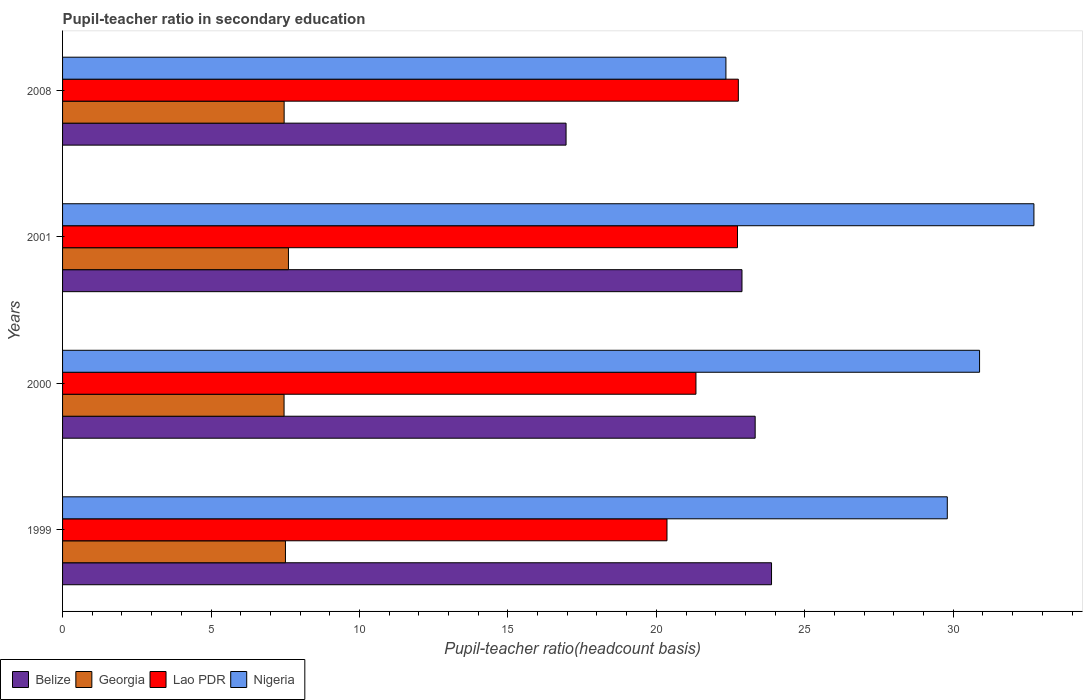How many different coloured bars are there?
Provide a short and direct response. 4. Are the number of bars per tick equal to the number of legend labels?
Keep it short and to the point. Yes. Are the number of bars on each tick of the Y-axis equal?
Ensure brevity in your answer.  Yes. How many bars are there on the 1st tick from the top?
Your answer should be compact. 4. What is the pupil-teacher ratio in secondary education in Lao PDR in 2008?
Ensure brevity in your answer.  22.76. Across all years, what is the maximum pupil-teacher ratio in secondary education in Lao PDR?
Your answer should be compact. 22.76. Across all years, what is the minimum pupil-teacher ratio in secondary education in Nigeria?
Provide a short and direct response. 22.34. In which year was the pupil-teacher ratio in secondary education in Lao PDR minimum?
Your response must be concise. 1999. What is the total pupil-teacher ratio in secondary education in Georgia in the graph?
Keep it short and to the point. 30.04. What is the difference between the pupil-teacher ratio in secondary education in Lao PDR in 1999 and that in 2000?
Offer a very short reply. -0.98. What is the difference between the pupil-teacher ratio in secondary education in Nigeria in 2000 and the pupil-teacher ratio in secondary education in Georgia in 2008?
Your answer should be very brief. 23.42. What is the average pupil-teacher ratio in secondary education in Nigeria per year?
Keep it short and to the point. 28.94. In the year 2001, what is the difference between the pupil-teacher ratio in secondary education in Georgia and pupil-teacher ratio in secondary education in Nigeria?
Provide a short and direct response. -25.11. What is the ratio of the pupil-teacher ratio in secondary education in Georgia in 2000 to that in 2001?
Your response must be concise. 0.98. What is the difference between the highest and the second highest pupil-teacher ratio in secondary education in Nigeria?
Keep it short and to the point. 1.83. What is the difference between the highest and the lowest pupil-teacher ratio in secondary education in Nigeria?
Provide a short and direct response. 10.37. In how many years, is the pupil-teacher ratio in secondary education in Georgia greater than the average pupil-teacher ratio in secondary education in Georgia taken over all years?
Give a very brief answer. 1. Is the sum of the pupil-teacher ratio in secondary education in Lao PDR in 1999 and 2008 greater than the maximum pupil-teacher ratio in secondary education in Georgia across all years?
Provide a short and direct response. Yes. Is it the case that in every year, the sum of the pupil-teacher ratio in secondary education in Nigeria and pupil-teacher ratio in secondary education in Belize is greater than the sum of pupil-teacher ratio in secondary education in Georgia and pupil-teacher ratio in secondary education in Lao PDR?
Give a very brief answer. No. What does the 1st bar from the top in 1999 represents?
Give a very brief answer. Nigeria. What does the 4th bar from the bottom in 2008 represents?
Give a very brief answer. Nigeria. How many bars are there?
Provide a succinct answer. 16. Are all the bars in the graph horizontal?
Offer a very short reply. Yes. Does the graph contain grids?
Make the answer very short. No. How many legend labels are there?
Offer a very short reply. 4. How are the legend labels stacked?
Offer a terse response. Horizontal. What is the title of the graph?
Your answer should be compact. Pupil-teacher ratio in secondary education. Does "East Asia (developing only)" appear as one of the legend labels in the graph?
Ensure brevity in your answer.  No. What is the label or title of the X-axis?
Make the answer very short. Pupil-teacher ratio(headcount basis). What is the label or title of the Y-axis?
Your answer should be compact. Years. What is the Pupil-teacher ratio(headcount basis) of Belize in 1999?
Offer a terse response. 23.88. What is the Pupil-teacher ratio(headcount basis) of Georgia in 1999?
Offer a terse response. 7.51. What is the Pupil-teacher ratio(headcount basis) of Lao PDR in 1999?
Your response must be concise. 20.36. What is the Pupil-teacher ratio(headcount basis) in Nigeria in 1999?
Provide a short and direct response. 29.8. What is the Pupil-teacher ratio(headcount basis) in Belize in 2000?
Provide a succinct answer. 23.33. What is the Pupil-teacher ratio(headcount basis) in Georgia in 2000?
Keep it short and to the point. 7.46. What is the Pupil-teacher ratio(headcount basis) of Lao PDR in 2000?
Provide a short and direct response. 21.33. What is the Pupil-teacher ratio(headcount basis) in Nigeria in 2000?
Your response must be concise. 30.89. What is the Pupil-teacher ratio(headcount basis) of Belize in 2001?
Your answer should be compact. 22.88. What is the Pupil-teacher ratio(headcount basis) in Georgia in 2001?
Provide a short and direct response. 7.61. What is the Pupil-teacher ratio(headcount basis) in Lao PDR in 2001?
Ensure brevity in your answer.  22.73. What is the Pupil-teacher ratio(headcount basis) in Nigeria in 2001?
Give a very brief answer. 32.72. What is the Pupil-teacher ratio(headcount basis) of Belize in 2008?
Ensure brevity in your answer.  16.96. What is the Pupil-teacher ratio(headcount basis) in Georgia in 2008?
Make the answer very short. 7.46. What is the Pupil-teacher ratio(headcount basis) in Lao PDR in 2008?
Give a very brief answer. 22.76. What is the Pupil-teacher ratio(headcount basis) of Nigeria in 2008?
Keep it short and to the point. 22.34. Across all years, what is the maximum Pupil-teacher ratio(headcount basis) of Belize?
Your answer should be compact. 23.88. Across all years, what is the maximum Pupil-teacher ratio(headcount basis) of Georgia?
Your response must be concise. 7.61. Across all years, what is the maximum Pupil-teacher ratio(headcount basis) in Lao PDR?
Ensure brevity in your answer.  22.76. Across all years, what is the maximum Pupil-teacher ratio(headcount basis) in Nigeria?
Make the answer very short. 32.72. Across all years, what is the minimum Pupil-teacher ratio(headcount basis) of Belize?
Make the answer very short. 16.96. Across all years, what is the minimum Pupil-teacher ratio(headcount basis) in Georgia?
Make the answer very short. 7.46. Across all years, what is the minimum Pupil-teacher ratio(headcount basis) in Lao PDR?
Offer a terse response. 20.36. Across all years, what is the minimum Pupil-teacher ratio(headcount basis) of Nigeria?
Your answer should be very brief. 22.34. What is the total Pupil-teacher ratio(headcount basis) in Belize in the graph?
Offer a terse response. 87.05. What is the total Pupil-teacher ratio(headcount basis) of Georgia in the graph?
Your answer should be compact. 30.04. What is the total Pupil-teacher ratio(headcount basis) of Lao PDR in the graph?
Ensure brevity in your answer.  87.19. What is the total Pupil-teacher ratio(headcount basis) of Nigeria in the graph?
Provide a succinct answer. 115.75. What is the difference between the Pupil-teacher ratio(headcount basis) in Belize in 1999 and that in 2000?
Provide a succinct answer. 0.55. What is the difference between the Pupil-teacher ratio(headcount basis) of Georgia in 1999 and that in 2000?
Your answer should be very brief. 0.05. What is the difference between the Pupil-teacher ratio(headcount basis) of Lao PDR in 1999 and that in 2000?
Give a very brief answer. -0.98. What is the difference between the Pupil-teacher ratio(headcount basis) in Nigeria in 1999 and that in 2000?
Offer a terse response. -1.09. What is the difference between the Pupil-teacher ratio(headcount basis) in Belize in 1999 and that in 2001?
Make the answer very short. 1. What is the difference between the Pupil-teacher ratio(headcount basis) in Georgia in 1999 and that in 2001?
Your answer should be compact. -0.1. What is the difference between the Pupil-teacher ratio(headcount basis) in Lao PDR in 1999 and that in 2001?
Give a very brief answer. -2.37. What is the difference between the Pupil-teacher ratio(headcount basis) in Nigeria in 1999 and that in 2001?
Ensure brevity in your answer.  -2.92. What is the difference between the Pupil-teacher ratio(headcount basis) in Belize in 1999 and that in 2008?
Offer a very short reply. 6.92. What is the difference between the Pupil-teacher ratio(headcount basis) in Georgia in 1999 and that in 2008?
Your response must be concise. 0.04. What is the difference between the Pupil-teacher ratio(headcount basis) of Lao PDR in 1999 and that in 2008?
Your answer should be compact. -2.4. What is the difference between the Pupil-teacher ratio(headcount basis) of Nigeria in 1999 and that in 2008?
Keep it short and to the point. 7.46. What is the difference between the Pupil-teacher ratio(headcount basis) of Belize in 2000 and that in 2001?
Provide a succinct answer. 0.44. What is the difference between the Pupil-teacher ratio(headcount basis) in Georgia in 2000 and that in 2001?
Provide a short and direct response. -0.15. What is the difference between the Pupil-teacher ratio(headcount basis) of Lao PDR in 2000 and that in 2001?
Provide a short and direct response. -1.4. What is the difference between the Pupil-teacher ratio(headcount basis) in Nigeria in 2000 and that in 2001?
Offer a very short reply. -1.83. What is the difference between the Pupil-teacher ratio(headcount basis) in Belize in 2000 and that in 2008?
Give a very brief answer. 6.37. What is the difference between the Pupil-teacher ratio(headcount basis) in Georgia in 2000 and that in 2008?
Provide a succinct answer. -0. What is the difference between the Pupil-teacher ratio(headcount basis) in Lao PDR in 2000 and that in 2008?
Ensure brevity in your answer.  -1.43. What is the difference between the Pupil-teacher ratio(headcount basis) in Nigeria in 2000 and that in 2008?
Offer a very short reply. 8.54. What is the difference between the Pupil-teacher ratio(headcount basis) of Belize in 2001 and that in 2008?
Provide a short and direct response. 5.93. What is the difference between the Pupil-teacher ratio(headcount basis) in Georgia in 2001 and that in 2008?
Offer a terse response. 0.15. What is the difference between the Pupil-teacher ratio(headcount basis) in Lao PDR in 2001 and that in 2008?
Your answer should be compact. -0.03. What is the difference between the Pupil-teacher ratio(headcount basis) of Nigeria in 2001 and that in 2008?
Offer a very short reply. 10.37. What is the difference between the Pupil-teacher ratio(headcount basis) in Belize in 1999 and the Pupil-teacher ratio(headcount basis) in Georgia in 2000?
Give a very brief answer. 16.42. What is the difference between the Pupil-teacher ratio(headcount basis) in Belize in 1999 and the Pupil-teacher ratio(headcount basis) in Lao PDR in 2000?
Your answer should be compact. 2.55. What is the difference between the Pupil-teacher ratio(headcount basis) of Belize in 1999 and the Pupil-teacher ratio(headcount basis) of Nigeria in 2000?
Provide a succinct answer. -7.01. What is the difference between the Pupil-teacher ratio(headcount basis) in Georgia in 1999 and the Pupil-teacher ratio(headcount basis) in Lao PDR in 2000?
Offer a terse response. -13.83. What is the difference between the Pupil-teacher ratio(headcount basis) in Georgia in 1999 and the Pupil-teacher ratio(headcount basis) in Nigeria in 2000?
Your answer should be very brief. -23.38. What is the difference between the Pupil-teacher ratio(headcount basis) of Lao PDR in 1999 and the Pupil-teacher ratio(headcount basis) of Nigeria in 2000?
Make the answer very short. -10.53. What is the difference between the Pupil-teacher ratio(headcount basis) in Belize in 1999 and the Pupil-teacher ratio(headcount basis) in Georgia in 2001?
Provide a succinct answer. 16.27. What is the difference between the Pupil-teacher ratio(headcount basis) in Belize in 1999 and the Pupil-teacher ratio(headcount basis) in Lao PDR in 2001?
Keep it short and to the point. 1.15. What is the difference between the Pupil-teacher ratio(headcount basis) in Belize in 1999 and the Pupil-teacher ratio(headcount basis) in Nigeria in 2001?
Provide a succinct answer. -8.84. What is the difference between the Pupil-teacher ratio(headcount basis) of Georgia in 1999 and the Pupil-teacher ratio(headcount basis) of Lao PDR in 2001?
Ensure brevity in your answer.  -15.23. What is the difference between the Pupil-teacher ratio(headcount basis) in Georgia in 1999 and the Pupil-teacher ratio(headcount basis) in Nigeria in 2001?
Offer a terse response. -25.21. What is the difference between the Pupil-teacher ratio(headcount basis) in Lao PDR in 1999 and the Pupil-teacher ratio(headcount basis) in Nigeria in 2001?
Offer a terse response. -12.36. What is the difference between the Pupil-teacher ratio(headcount basis) in Belize in 1999 and the Pupil-teacher ratio(headcount basis) in Georgia in 2008?
Keep it short and to the point. 16.42. What is the difference between the Pupil-teacher ratio(headcount basis) of Belize in 1999 and the Pupil-teacher ratio(headcount basis) of Lao PDR in 2008?
Provide a short and direct response. 1.12. What is the difference between the Pupil-teacher ratio(headcount basis) in Belize in 1999 and the Pupil-teacher ratio(headcount basis) in Nigeria in 2008?
Your answer should be very brief. 1.54. What is the difference between the Pupil-teacher ratio(headcount basis) of Georgia in 1999 and the Pupil-teacher ratio(headcount basis) of Lao PDR in 2008?
Your answer should be very brief. -15.25. What is the difference between the Pupil-teacher ratio(headcount basis) in Georgia in 1999 and the Pupil-teacher ratio(headcount basis) in Nigeria in 2008?
Provide a short and direct response. -14.84. What is the difference between the Pupil-teacher ratio(headcount basis) of Lao PDR in 1999 and the Pupil-teacher ratio(headcount basis) of Nigeria in 2008?
Your answer should be compact. -1.99. What is the difference between the Pupil-teacher ratio(headcount basis) in Belize in 2000 and the Pupil-teacher ratio(headcount basis) in Georgia in 2001?
Offer a terse response. 15.72. What is the difference between the Pupil-teacher ratio(headcount basis) of Belize in 2000 and the Pupil-teacher ratio(headcount basis) of Lao PDR in 2001?
Provide a succinct answer. 0.6. What is the difference between the Pupil-teacher ratio(headcount basis) of Belize in 2000 and the Pupil-teacher ratio(headcount basis) of Nigeria in 2001?
Ensure brevity in your answer.  -9.39. What is the difference between the Pupil-teacher ratio(headcount basis) of Georgia in 2000 and the Pupil-teacher ratio(headcount basis) of Lao PDR in 2001?
Keep it short and to the point. -15.27. What is the difference between the Pupil-teacher ratio(headcount basis) of Georgia in 2000 and the Pupil-teacher ratio(headcount basis) of Nigeria in 2001?
Give a very brief answer. -25.26. What is the difference between the Pupil-teacher ratio(headcount basis) of Lao PDR in 2000 and the Pupil-teacher ratio(headcount basis) of Nigeria in 2001?
Offer a very short reply. -11.38. What is the difference between the Pupil-teacher ratio(headcount basis) of Belize in 2000 and the Pupil-teacher ratio(headcount basis) of Georgia in 2008?
Your response must be concise. 15.87. What is the difference between the Pupil-teacher ratio(headcount basis) in Belize in 2000 and the Pupil-teacher ratio(headcount basis) in Lao PDR in 2008?
Offer a terse response. 0.57. What is the difference between the Pupil-teacher ratio(headcount basis) of Belize in 2000 and the Pupil-teacher ratio(headcount basis) of Nigeria in 2008?
Provide a short and direct response. 0.98. What is the difference between the Pupil-teacher ratio(headcount basis) of Georgia in 2000 and the Pupil-teacher ratio(headcount basis) of Lao PDR in 2008?
Give a very brief answer. -15.3. What is the difference between the Pupil-teacher ratio(headcount basis) of Georgia in 2000 and the Pupil-teacher ratio(headcount basis) of Nigeria in 2008?
Make the answer very short. -14.88. What is the difference between the Pupil-teacher ratio(headcount basis) of Lao PDR in 2000 and the Pupil-teacher ratio(headcount basis) of Nigeria in 2008?
Provide a succinct answer. -1.01. What is the difference between the Pupil-teacher ratio(headcount basis) in Belize in 2001 and the Pupil-teacher ratio(headcount basis) in Georgia in 2008?
Offer a terse response. 15.42. What is the difference between the Pupil-teacher ratio(headcount basis) of Belize in 2001 and the Pupil-teacher ratio(headcount basis) of Lao PDR in 2008?
Your answer should be very brief. 0.12. What is the difference between the Pupil-teacher ratio(headcount basis) of Belize in 2001 and the Pupil-teacher ratio(headcount basis) of Nigeria in 2008?
Offer a very short reply. 0.54. What is the difference between the Pupil-teacher ratio(headcount basis) in Georgia in 2001 and the Pupil-teacher ratio(headcount basis) in Lao PDR in 2008?
Provide a short and direct response. -15.15. What is the difference between the Pupil-teacher ratio(headcount basis) of Georgia in 2001 and the Pupil-teacher ratio(headcount basis) of Nigeria in 2008?
Your answer should be very brief. -14.73. What is the difference between the Pupil-teacher ratio(headcount basis) in Lao PDR in 2001 and the Pupil-teacher ratio(headcount basis) in Nigeria in 2008?
Offer a terse response. 0.39. What is the average Pupil-teacher ratio(headcount basis) of Belize per year?
Keep it short and to the point. 21.76. What is the average Pupil-teacher ratio(headcount basis) of Georgia per year?
Your answer should be very brief. 7.51. What is the average Pupil-teacher ratio(headcount basis) of Lao PDR per year?
Offer a terse response. 21.8. What is the average Pupil-teacher ratio(headcount basis) of Nigeria per year?
Offer a very short reply. 28.94. In the year 1999, what is the difference between the Pupil-teacher ratio(headcount basis) of Belize and Pupil-teacher ratio(headcount basis) of Georgia?
Provide a short and direct response. 16.37. In the year 1999, what is the difference between the Pupil-teacher ratio(headcount basis) in Belize and Pupil-teacher ratio(headcount basis) in Lao PDR?
Offer a terse response. 3.52. In the year 1999, what is the difference between the Pupil-teacher ratio(headcount basis) in Belize and Pupil-teacher ratio(headcount basis) in Nigeria?
Provide a succinct answer. -5.92. In the year 1999, what is the difference between the Pupil-teacher ratio(headcount basis) in Georgia and Pupil-teacher ratio(headcount basis) in Lao PDR?
Provide a succinct answer. -12.85. In the year 1999, what is the difference between the Pupil-teacher ratio(headcount basis) in Georgia and Pupil-teacher ratio(headcount basis) in Nigeria?
Ensure brevity in your answer.  -22.29. In the year 1999, what is the difference between the Pupil-teacher ratio(headcount basis) in Lao PDR and Pupil-teacher ratio(headcount basis) in Nigeria?
Your response must be concise. -9.44. In the year 2000, what is the difference between the Pupil-teacher ratio(headcount basis) of Belize and Pupil-teacher ratio(headcount basis) of Georgia?
Offer a very short reply. 15.87. In the year 2000, what is the difference between the Pupil-teacher ratio(headcount basis) of Belize and Pupil-teacher ratio(headcount basis) of Lao PDR?
Your answer should be compact. 1.99. In the year 2000, what is the difference between the Pupil-teacher ratio(headcount basis) in Belize and Pupil-teacher ratio(headcount basis) in Nigeria?
Provide a short and direct response. -7.56. In the year 2000, what is the difference between the Pupil-teacher ratio(headcount basis) in Georgia and Pupil-teacher ratio(headcount basis) in Lao PDR?
Provide a short and direct response. -13.87. In the year 2000, what is the difference between the Pupil-teacher ratio(headcount basis) in Georgia and Pupil-teacher ratio(headcount basis) in Nigeria?
Offer a terse response. -23.43. In the year 2000, what is the difference between the Pupil-teacher ratio(headcount basis) in Lao PDR and Pupil-teacher ratio(headcount basis) in Nigeria?
Give a very brief answer. -9.55. In the year 2001, what is the difference between the Pupil-teacher ratio(headcount basis) in Belize and Pupil-teacher ratio(headcount basis) in Georgia?
Make the answer very short. 15.28. In the year 2001, what is the difference between the Pupil-teacher ratio(headcount basis) of Belize and Pupil-teacher ratio(headcount basis) of Lao PDR?
Provide a short and direct response. 0.15. In the year 2001, what is the difference between the Pupil-teacher ratio(headcount basis) of Belize and Pupil-teacher ratio(headcount basis) of Nigeria?
Give a very brief answer. -9.83. In the year 2001, what is the difference between the Pupil-teacher ratio(headcount basis) in Georgia and Pupil-teacher ratio(headcount basis) in Lao PDR?
Offer a very short reply. -15.12. In the year 2001, what is the difference between the Pupil-teacher ratio(headcount basis) in Georgia and Pupil-teacher ratio(headcount basis) in Nigeria?
Provide a succinct answer. -25.11. In the year 2001, what is the difference between the Pupil-teacher ratio(headcount basis) in Lao PDR and Pupil-teacher ratio(headcount basis) in Nigeria?
Provide a short and direct response. -9.98. In the year 2008, what is the difference between the Pupil-teacher ratio(headcount basis) of Belize and Pupil-teacher ratio(headcount basis) of Georgia?
Provide a short and direct response. 9.5. In the year 2008, what is the difference between the Pupil-teacher ratio(headcount basis) of Belize and Pupil-teacher ratio(headcount basis) of Lao PDR?
Offer a terse response. -5.8. In the year 2008, what is the difference between the Pupil-teacher ratio(headcount basis) of Belize and Pupil-teacher ratio(headcount basis) of Nigeria?
Provide a succinct answer. -5.38. In the year 2008, what is the difference between the Pupil-teacher ratio(headcount basis) of Georgia and Pupil-teacher ratio(headcount basis) of Lao PDR?
Offer a very short reply. -15.3. In the year 2008, what is the difference between the Pupil-teacher ratio(headcount basis) of Georgia and Pupil-teacher ratio(headcount basis) of Nigeria?
Make the answer very short. -14.88. In the year 2008, what is the difference between the Pupil-teacher ratio(headcount basis) of Lao PDR and Pupil-teacher ratio(headcount basis) of Nigeria?
Ensure brevity in your answer.  0.42. What is the ratio of the Pupil-teacher ratio(headcount basis) of Belize in 1999 to that in 2000?
Offer a very short reply. 1.02. What is the ratio of the Pupil-teacher ratio(headcount basis) of Lao PDR in 1999 to that in 2000?
Your answer should be very brief. 0.95. What is the ratio of the Pupil-teacher ratio(headcount basis) in Nigeria in 1999 to that in 2000?
Your answer should be compact. 0.96. What is the ratio of the Pupil-teacher ratio(headcount basis) of Belize in 1999 to that in 2001?
Offer a terse response. 1.04. What is the ratio of the Pupil-teacher ratio(headcount basis) in Georgia in 1999 to that in 2001?
Keep it short and to the point. 0.99. What is the ratio of the Pupil-teacher ratio(headcount basis) in Lao PDR in 1999 to that in 2001?
Keep it short and to the point. 0.9. What is the ratio of the Pupil-teacher ratio(headcount basis) of Nigeria in 1999 to that in 2001?
Make the answer very short. 0.91. What is the ratio of the Pupil-teacher ratio(headcount basis) in Belize in 1999 to that in 2008?
Your answer should be very brief. 1.41. What is the ratio of the Pupil-teacher ratio(headcount basis) in Georgia in 1999 to that in 2008?
Your answer should be very brief. 1.01. What is the ratio of the Pupil-teacher ratio(headcount basis) in Lao PDR in 1999 to that in 2008?
Offer a very short reply. 0.89. What is the ratio of the Pupil-teacher ratio(headcount basis) in Nigeria in 1999 to that in 2008?
Offer a very short reply. 1.33. What is the ratio of the Pupil-teacher ratio(headcount basis) in Belize in 2000 to that in 2001?
Your answer should be very brief. 1.02. What is the ratio of the Pupil-teacher ratio(headcount basis) of Georgia in 2000 to that in 2001?
Provide a succinct answer. 0.98. What is the ratio of the Pupil-teacher ratio(headcount basis) of Lao PDR in 2000 to that in 2001?
Keep it short and to the point. 0.94. What is the ratio of the Pupil-teacher ratio(headcount basis) of Nigeria in 2000 to that in 2001?
Keep it short and to the point. 0.94. What is the ratio of the Pupil-teacher ratio(headcount basis) of Belize in 2000 to that in 2008?
Give a very brief answer. 1.38. What is the ratio of the Pupil-teacher ratio(headcount basis) in Georgia in 2000 to that in 2008?
Your answer should be very brief. 1. What is the ratio of the Pupil-teacher ratio(headcount basis) of Lao PDR in 2000 to that in 2008?
Your answer should be compact. 0.94. What is the ratio of the Pupil-teacher ratio(headcount basis) of Nigeria in 2000 to that in 2008?
Your answer should be compact. 1.38. What is the ratio of the Pupil-teacher ratio(headcount basis) of Belize in 2001 to that in 2008?
Provide a succinct answer. 1.35. What is the ratio of the Pupil-teacher ratio(headcount basis) of Georgia in 2001 to that in 2008?
Provide a short and direct response. 1.02. What is the ratio of the Pupil-teacher ratio(headcount basis) of Nigeria in 2001 to that in 2008?
Provide a short and direct response. 1.46. What is the difference between the highest and the second highest Pupil-teacher ratio(headcount basis) of Belize?
Make the answer very short. 0.55. What is the difference between the highest and the second highest Pupil-teacher ratio(headcount basis) of Georgia?
Your response must be concise. 0.1. What is the difference between the highest and the second highest Pupil-teacher ratio(headcount basis) of Lao PDR?
Make the answer very short. 0.03. What is the difference between the highest and the second highest Pupil-teacher ratio(headcount basis) in Nigeria?
Make the answer very short. 1.83. What is the difference between the highest and the lowest Pupil-teacher ratio(headcount basis) of Belize?
Your answer should be very brief. 6.92. What is the difference between the highest and the lowest Pupil-teacher ratio(headcount basis) in Georgia?
Your answer should be very brief. 0.15. What is the difference between the highest and the lowest Pupil-teacher ratio(headcount basis) of Lao PDR?
Offer a terse response. 2.4. What is the difference between the highest and the lowest Pupil-teacher ratio(headcount basis) in Nigeria?
Your response must be concise. 10.37. 